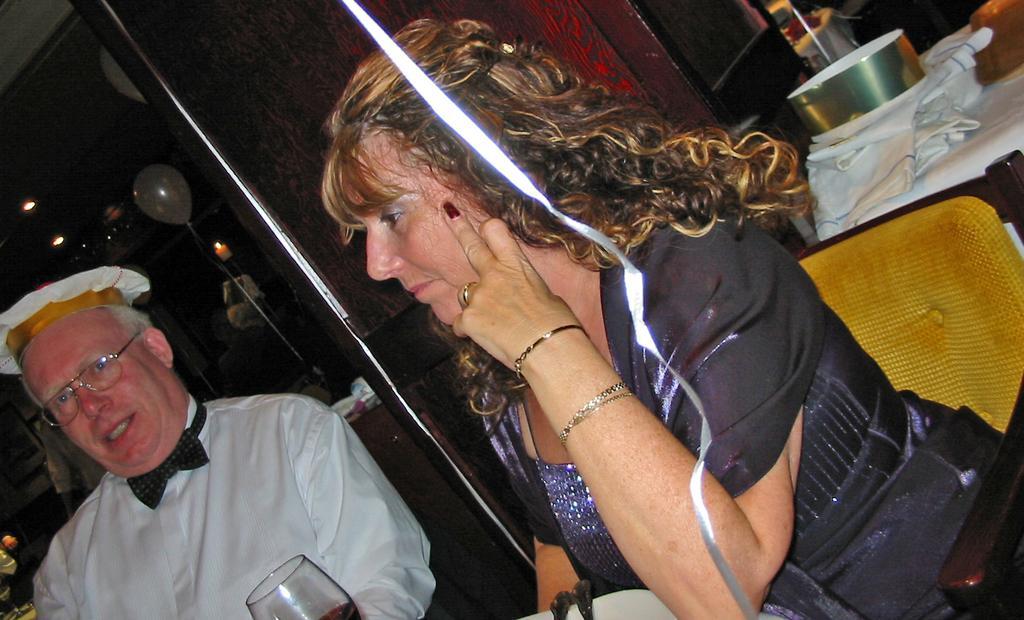How would you summarize this image in a sentence or two? In this image we can see few people sitting on the chairs. There is a drink glass at the bottom of the image. There are few spoons on the plate at the bottom of the image. There are few object at the right side of the image. We can see few reflections on the glass in the image. 